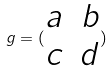<formula> <loc_0><loc_0><loc_500><loc_500>g = ( \begin{matrix} a & b \\ c & d \end{matrix} )</formula> 